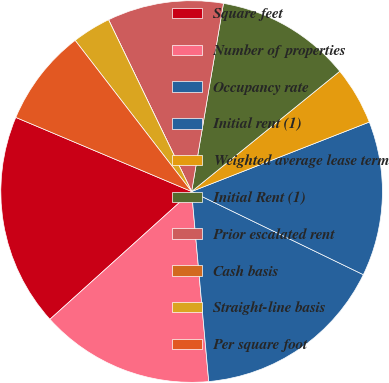Convert chart to OTSL. <chart><loc_0><loc_0><loc_500><loc_500><pie_chart><fcel>Square feet<fcel>Number of properties<fcel>Occupancy rate<fcel>Initial rent (1)<fcel>Weighted average lease term<fcel>Initial Rent (1)<fcel>Prior escalated rent<fcel>Cash basis<fcel>Straight-line basis<fcel>Per square foot<nl><fcel>18.03%<fcel>14.75%<fcel>16.39%<fcel>13.11%<fcel>4.92%<fcel>11.48%<fcel>9.84%<fcel>0.0%<fcel>3.28%<fcel>8.2%<nl></chart> 